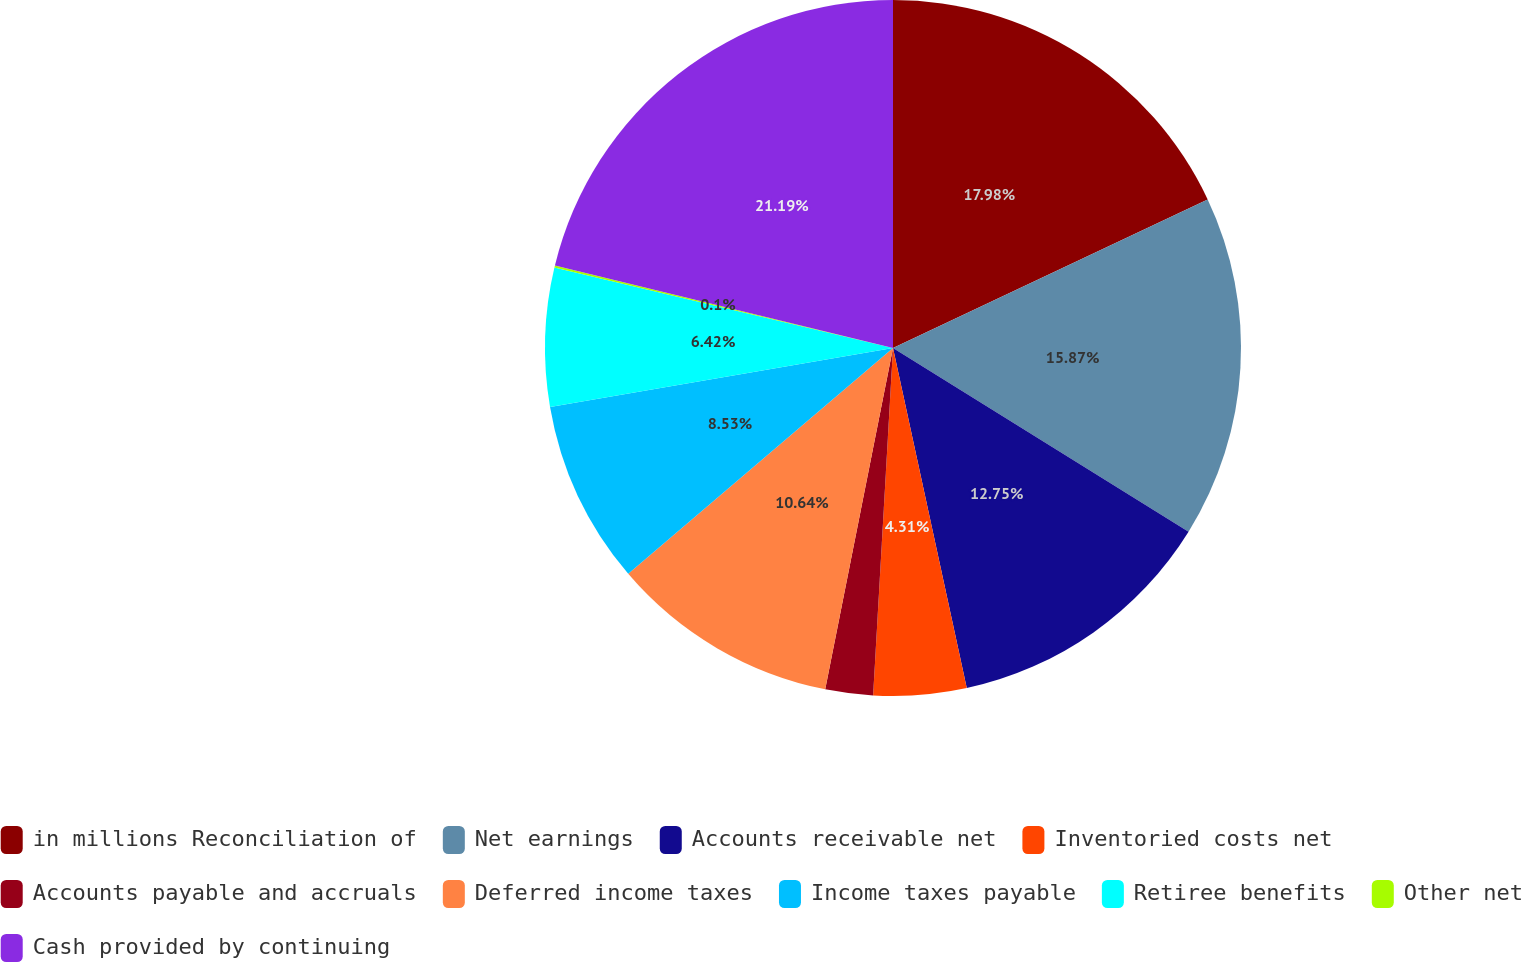<chart> <loc_0><loc_0><loc_500><loc_500><pie_chart><fcel>in millions Reconciliation of<fcel>Net earnings<fcel>Accounts receivable net<fcel>Inventoried costs net<fcel>Accounts payable and accruals<fcel>Deferred income taxes<fcel>Income taxes payable<fcel>Retiree benefits<fcel>Other net<fcel>Cash provided by continuing<nl><fcel>17.98%<fcel>15.87%<fcel>12.75%<fcel>4.31%<fcel>2.21%<fcel>10.64%<fcel>8.53%<fcel>6.42%<fcel>0.1%<fcel>21.19%<nl></chart> 